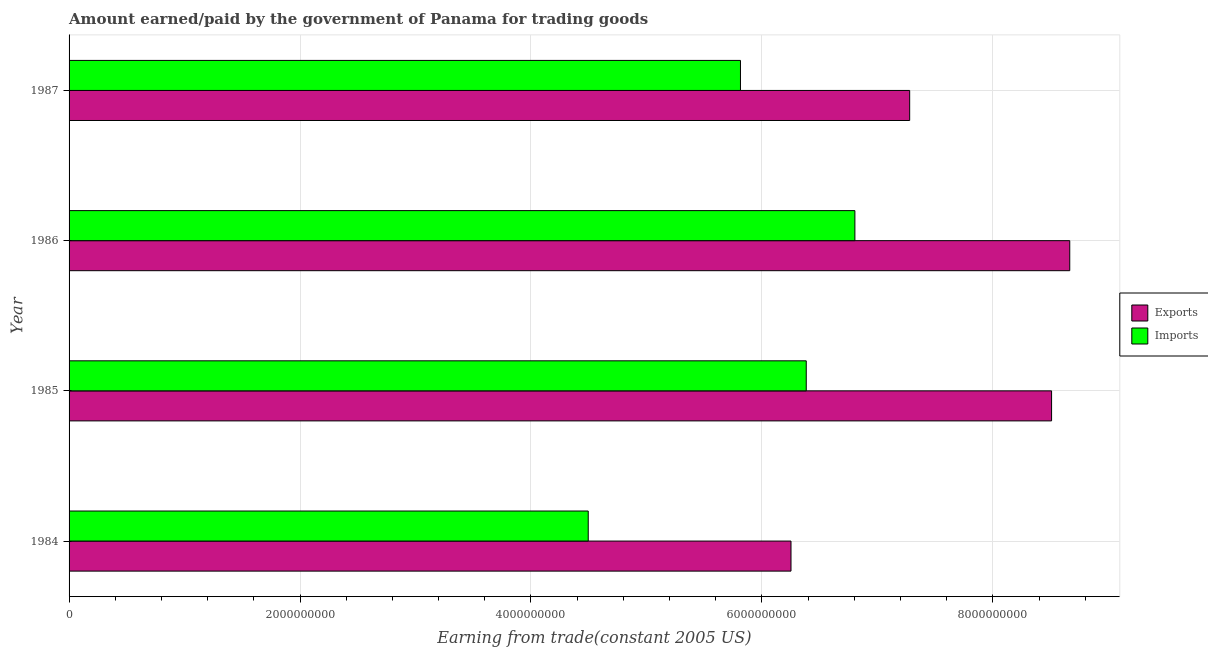Are the number of bars per tick equal to the number of legend labels?
Ensure brevity in your answer.  Yes. Are the number of bars on each tick of the Y-axis equal?
Offer a terse response. Yes. How many bars are there on the 1st tick from the top?
Your answer should be compact. 2. How many bars are there on the 4th tick from the bottom?
Your response must be concise. 2. What is the label of the 4th group of bars from the top?
Provide a succinct answer. 1984. What is the amount paid for imports in 1987?
Provide a succinct answer. 5.81e+09. Across all years, what is the maximum amount paid for imports?
Ensure brevity in your answer.  6.81e+09. Across all years, what is the minimum amount paid for imports?
Provide a short and direct response. 4.50e+09. In which year was the amount earned from exports minimum?
Keep it short and to the point. 1984. What is the total amount earned from exports in the graph?
Provide a succinct answer. 3.07e+1. What is the difference between the amount earned from exports in 1984 and that in 1986?
Your answer should be compact. -2.41e+09. What is the difference between the amount earned from exports in 1987 and the amount paid for imports in 1986?
Your response must be concise. 4.74e+08. What is the average amount paid for imports per year?
Keep it short and to the point. 5.87e+09. In the year 1984, what is the difference between the amount paid for imports and amount earned from exports?
Your answer should be very brief. -1.76e+09. In how many years, is the amount paid for imports greater than 8400000000 US$?
Your response must be concise. 0. What is the ratio of the amount earned from exports in 1984 to that in 1985?
Your response must be concise. 0.73. Is the amount earned from exports in 1985 less than that in 1986?
Provide a short and direct response. Yes. What is the difference between the highest and the second highest amount earned from exports?
Offer a terse response. 1.57e+08. What is the difference between the highest and the lowest amount paid for imports?
Make the answer very short. 2.31e+09. Is the sum of the amount paid for imports in 1985 and 1987 greater than the maximum amount earned from exports across all years?
Your response must be concise. Yes. What does the 1st bar from the top in 1986 represents?
Provide a succinct answer. Imports. What does the 1st bar from the bottom in 1987 represents?
Offer a terse response. Exports. Are all the bars in the graph horizontal?
Your answer should be compact. Yes. What is the difference between two consecutive major ticks on the X-axis?
Your answer should be compact. 2.00e+09. What is the title of the graph?
Offer a very short reply. Amount earned/paid by the government of Panama for trading goods. Does "Taxes on profits and capital gains" appear as one of the legend labels in the graph?
Provide a short and direct response. No. What is the label or title of the X-axis?
Give a very brief answer. Earning from trade(constant 2005 US). What is the label or title of the Y-axis?
Offer a very short reply. Year. What is the Earning from trade(constant 2005 US) of Exports in 1984?
Offer a very short reply. 6.25e+09. What is the Earning from trade(constant 2005 US) in Imports in 1984?
Your response must be concise. 4.50e+09. What is the Earning from trade(constant 2005 US) in Exports in 1985?
Provide a succinct answer. 8.51e+09. What is the Earning from trade(constant 2005 US) of Imports in 1985?
Offer a terse response. 6.38e+09. What is the Earning from trade(constant 2005 US) in Exports in 1986?
Provide a succinct answer. 8.67e+09. What is the Earning from trade(constant 2005 US) of Imports in 1986?
Give a very brief answer. 6.81e+09. What is the Earning from trade(constant 2005 US) in Exports in 1987?
Provide a short and direct response. 7.28e+09. What is the Earning from trade(constant 2005 US) in Imports in 1987?
Offer a very short reply. 5.81e+09. Across all years, what is the maximum Earning from trade(constant 2005 US) of Exports?
Give a very brief answer. 8.67e+09. Across all years, what is the maximum Earning from trade(constant 2005 US) of Imports?
Keep it short and to the point. 6.81e+09. Across all years, what is the minimum Earning from trade(constant 2005 US) of Exports?
Your answer should be very brief. 6.25e+09. Across all years, what is the minimum Earning from trade(constant 2005 US) of Imports?
Give a very brief answer. 4.50e+09. What is the total Earning from trade(constant 2005 US) in Exports in the graph?
Keep it short and to the point. 3.07e+1. What is the total Earning from trade(constant 2005 US) in Imports in the graph?
Provide a succinct answer. 2.35e+1. What is the difference between the Earning from trade(constant 2005 US) of Exports in 1984 and that in 1985?
Your response must be concise. -2.26e+09. What is the difference between the Earning from trade(constant 2005 US) in Imports in 1984 and that in 1985?
Make the answer very short. -1.89e+09. What is the difference between the Earning from trade(constant 2005 US) of Exports in 1984 and that in 1986?
Your answer should be very brief. -2.41e+09. What is the difference between the Earning from trade(constant 2005 US) of Imports in 1984 and that in 1986?
Your answer should be compact. -2.31e+09. What is the difference between the Earning from trade(constant 2005 US) of Exports in 1984 and that in 1987?
Provide a succinct answer. -1.03e+09. What is the difference between the Earning from trade(constant 2005 US) in Imports in 1984 and that in 1987?
Your answer should be very brief. -1.32e+09. What is the difference between the Earning from trade(constant 2005 US) of Exports in 1985 and that in 1986?
Keep it short and to the point. -1.57e+08. What is the difference between the Earning from trade(constant 2005 US) in Imports in 1985 and that in 1986?
Give a very brief answer. -4.21e+08. What is the difference between the Earning from trade(constant 2005 US) of Exports in 1985 and that in 1987?
Provide a short and direct response. 1.23e+09. What is the difference between the Earning from trade(constant 2005 US) of Imports in 1985 and that in 1987?
Offer a very short reply. 5.70e+08. What is the difference between the Earning from trade(constant 2005 US) in Exports in 1986 and that in 1987?
Your answer should be compact. 1.39e+09. What is the difference between the Earning from trade(constant 2005 US) in Imports in 1986 and that in 1987?
Give a very brief answer. 9.91e+08. What is the difference between the Earning from trade(constant 2005 US) in Exports in 1984 and the Earning from trade(constant 2005 US) in Imports in 1985?
Your answer should be very brief. -1.32e+08. What is the difference between the Earning from trade(constant 2005 US) of Exports in 1984 and the Earning from trade(constant 2005 US) of Imports in 1986?
Offer a terse response. -5.53e+08. What is the difference between the Earning from trade(constant 2005 US) in Exports in 1984 and the Earning from trade(constant 2005 US) in Imports in 1987?
Your response must be concise. 4.38e+08. What is the difference between the Earning from trade(constant 2005 US) in Exports in 1985 and the Earning from trade(constant 2005 US) in Imports in 1986?
Ensure brevity in your answer.  1.70e+09. What is the difference between the Earning from trade(constant 2005 US) in Exports in 1985 and the Earning from trade(constant 2005 US) in Imports in 1987?
Provide a short and direct response. 2.69e+09. What is the difference between the Earning from trade(constant 2005 US) in Exports in 1986 and the Earning from trade(constant 2005 US) in Imports in 1987?
Make the answer very short. 2.85e+09. What is the average Earning from trade(constant 2005 US) of Exports per year?
Give a very brief answer. 7.68e+09. What is the average Earning from trade(constant 2005 US) of Imports per year?
Provide a short and direct response. 5.87e+09. In the year 1984, what is the difference between the Earning from trade(constant 2005 US) in Exports and Earning from trade(constant 2005 US) in Imports?
Ensure brevity in your answer.  1.76e+09. In the year 1985, what is the difference between the Earning from trade(constant 2005 US) of Exports and Earning from trade(constant 2005 US) of Imports?
Offer a terse response. 2.12e+09. In the year 1986, what is the difference between the Earning from trade(constant 2005 US) of Exports and Earning from trade(constant 2005 US) of Imports?
Your response must be concise. 1.86e+09. In the year 1987, what is the difference between the Earning from trade(constant 2005 US) of Exports and Earning from trade(constant 2005 US) of Imports?
Your answer should be very brief. 1.47e+09. What is the ratio of the Earning from trade(constant 2005 US) in Exports in 1984 to that in 1985?
Offer a very short reply. 0.73. What is the ratio of the Earning from trade(constant 2005 US) in Imports in 1984 to that in 1985?
Ensure brevity in your answer.  0.7. What is the ratio of the Earning from trade(constant 2005 US) of Exports in 1984 to that in 1986?
Your answer should be very brief. 0.72. What is the ratio of the Earning from trade(constant 2005 US) of Imports in 1984 to that in 1986?
Give a very brief answer. 0.66. What is the ratio of the Earning from trade(constant 2005 US) of Exports in 1984 to that in 1987?
Provide a succinct answer. 0.86. What is the ratio of the Earning from trade(constant 2005 US) in Imports in 1984 to that in 1987?
Offer a terse response. 0.77. What is the ratio of the Earning from trade(constant 2005 US) of Exports in 1985 to that in 1986?
Provide a short and direct response. 0.98. What is the ratio of the Earning from trade(constant 2005 US) in Imports in 1985 to that in 1986?
Ensure brevity in your answer.  0.94. What is the ratio of the Earning from trade(constant 2005 US) of Exports in 1985 to that in 1987?
Offer a very short reply. 1.17. What is the ratio of the Earning from trade(constant 2005 US) of Imports in 1985 to that in 1987?
Your response must be concise. 1.1. What is the ratio of the Earning from trade(constant 2005 US) of Exports in 1986 to that in 1987?
Your response must be concise. 1.19. What is the ratio of the Earning from trade(constant 2005 US) in Imports in 1986 to that in 1987?
Offer a terse response. 1.17. What is the difference between the highest and the second highest Earning from trade(constant 2005 US) in Exports?
Keep it short and to the point. 1.57e+08. What is the difference between the highest and the second highest Earning from trade(constant 2005 US) in Imports?
Your answer should be very brief. 4.21e+08. What is the difference between the highest and the lowest Earning from trade(constant 2005 US) in Exports?
Make the answer very short. 2.41e+09. What is the difference between the highest and the lowest Earning from trade(constant 2005 US) in Imports?
Your response must be concise. 2.31e+09. 